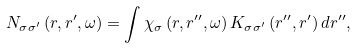Convert formula to latex. <formula><loc_0><loc_0><loc_500><loc_500>N _ { \sigma \sigma ^ { \prime } } \left ( r , r ^ { \prime } , \omega \right ) = \int \chi _ { \sigma } \left ( r , r ^ { \prime \prime } , \omega \right ) K _ { \sigma \sigma ^ { \prime } } \left ( r ^ { \prime \prime } , r ^ { \prime } \right ) d r ^ { \prime \prime } ,</formula> 